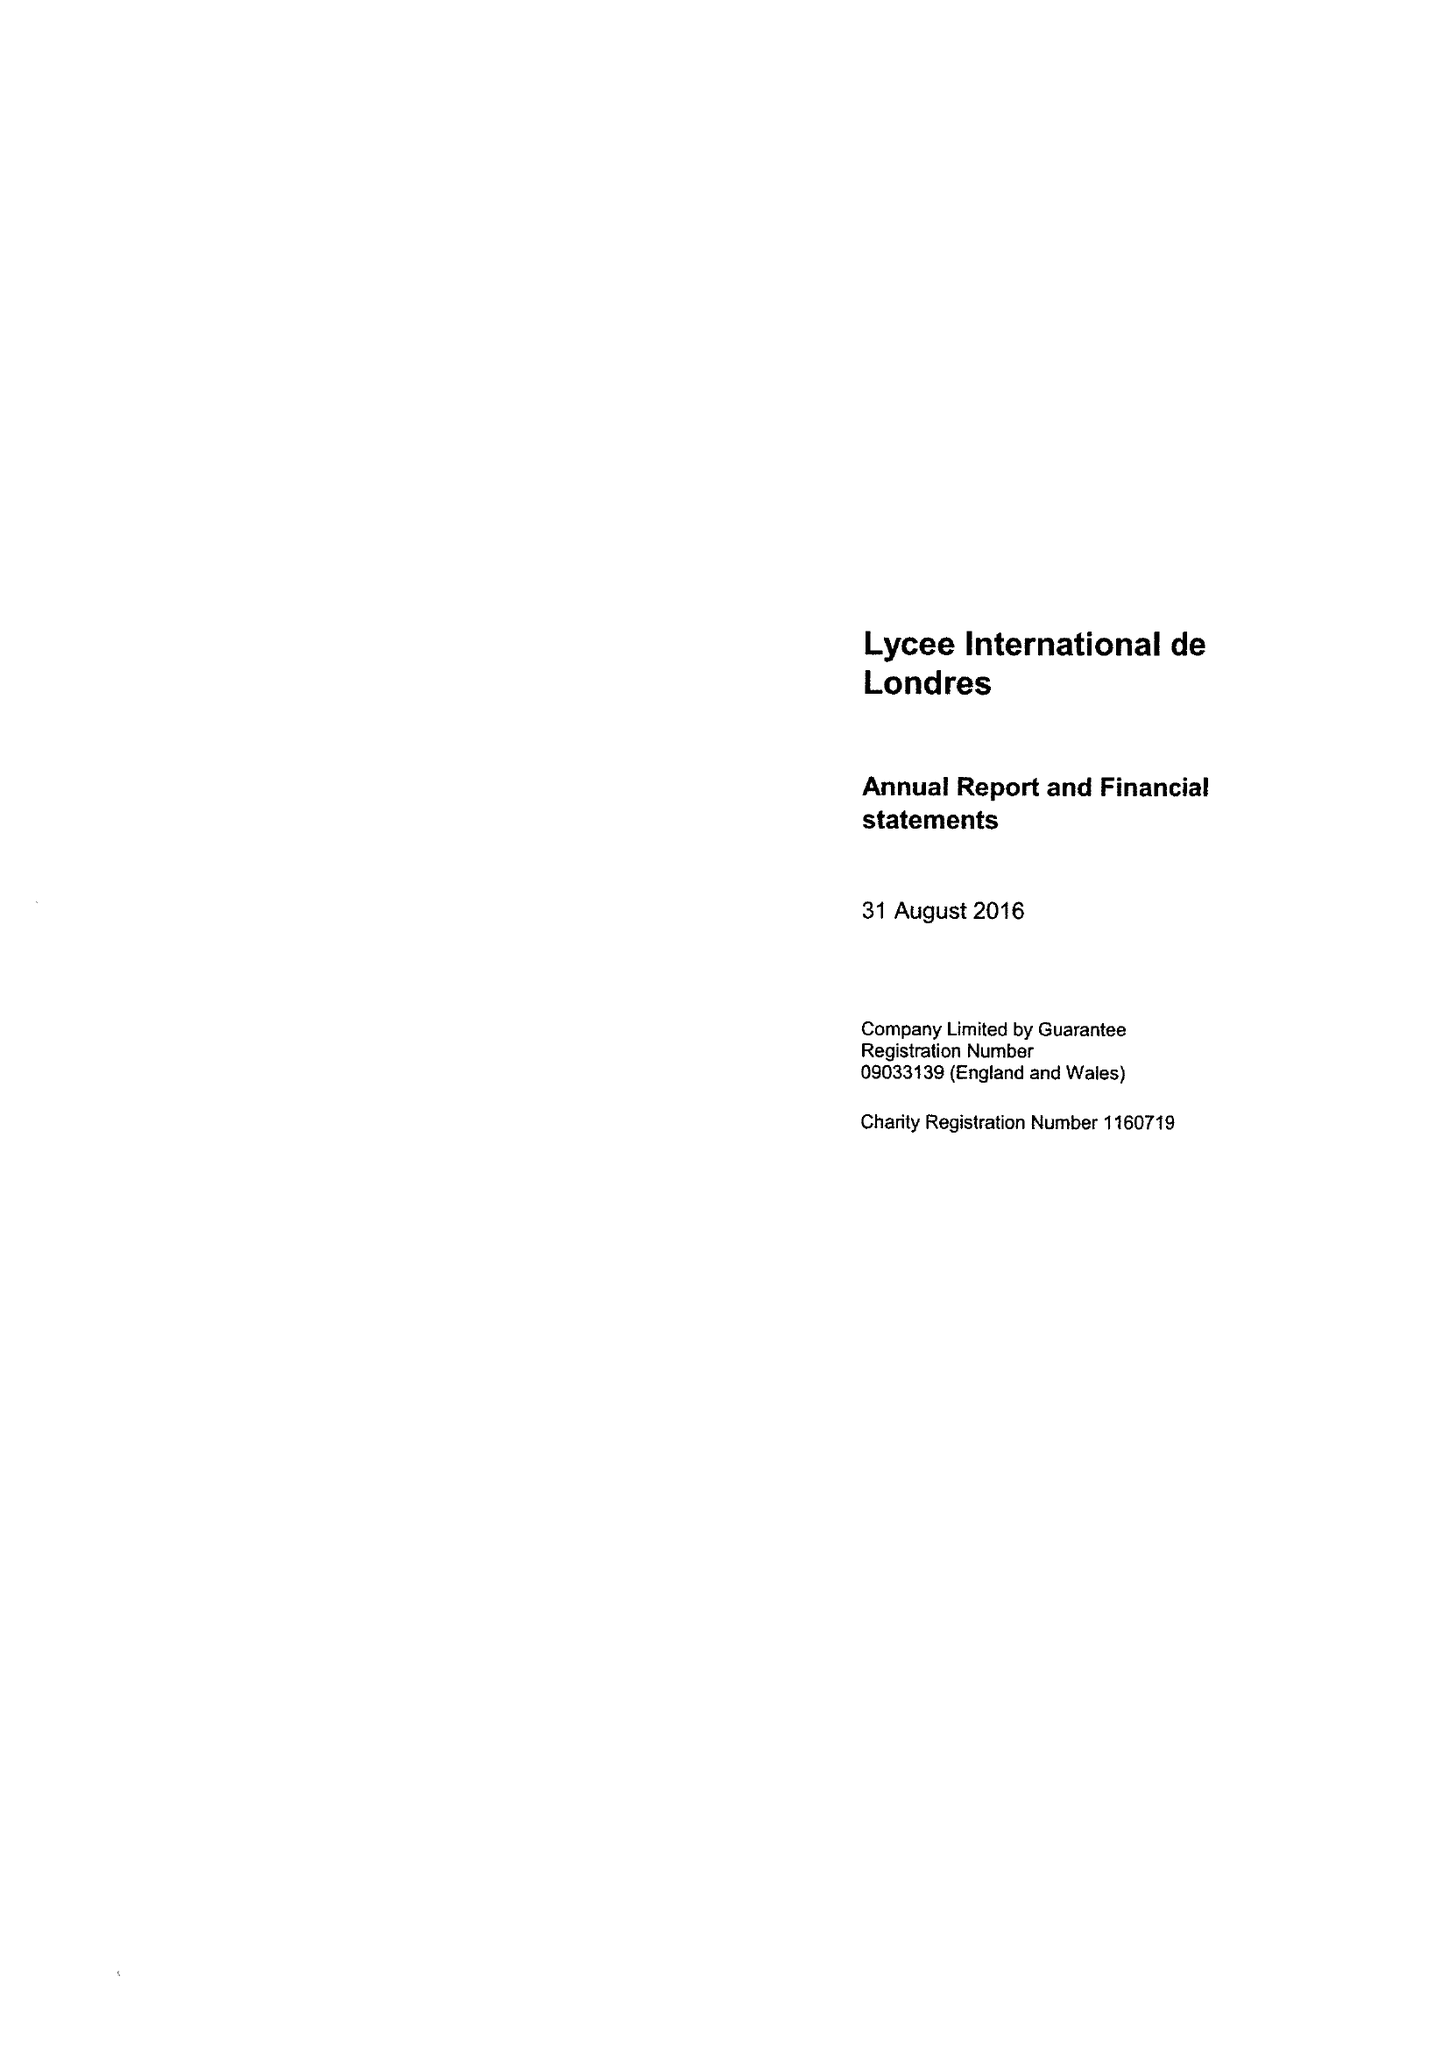What is the value for the address__postcode?
Answer the question using a single word or phrase. HA9 9LY 